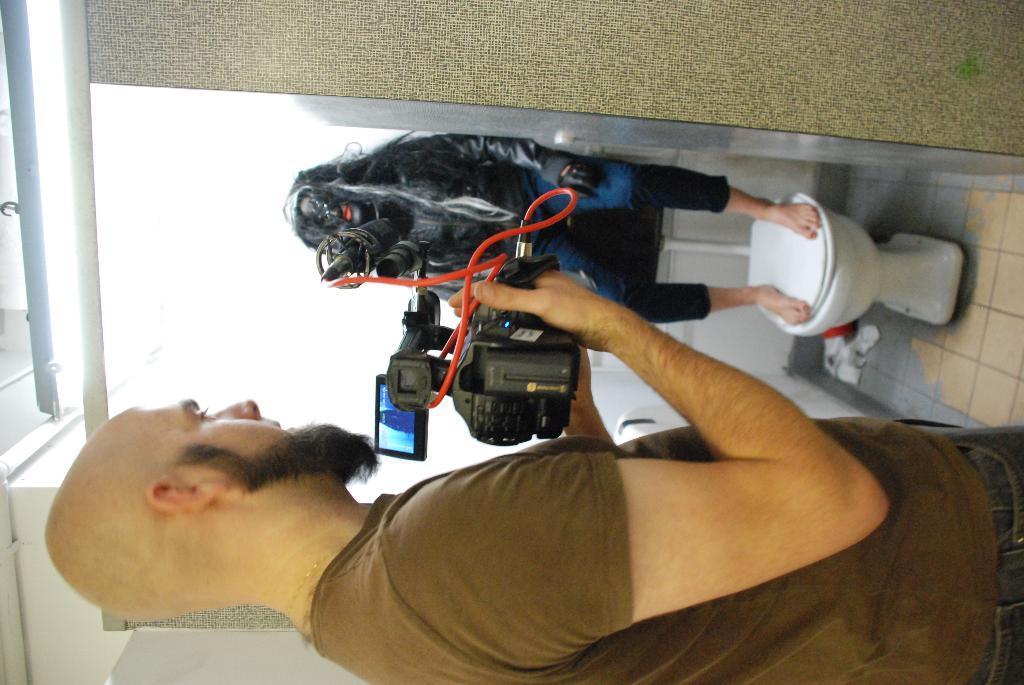Please provide a concise description of this image. In this picture we can see a man is holding a camera in the front, in the background we can see another person, on the right side there is a western commode, we can see a wall on the left side of the picture. 